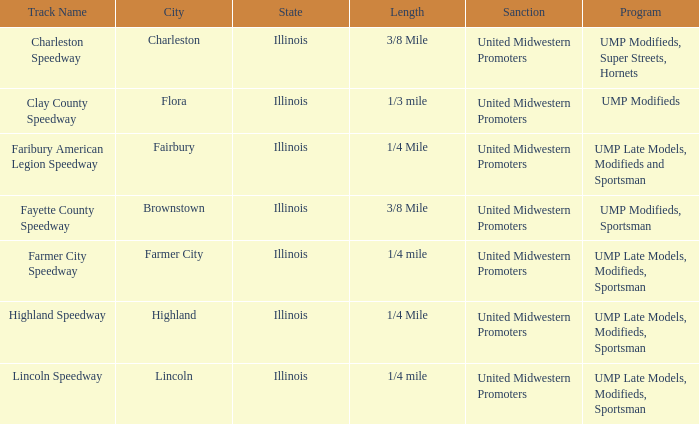What programs were held in charleston, illinois? UMP Modifieds, Super Streets, Hornets. 